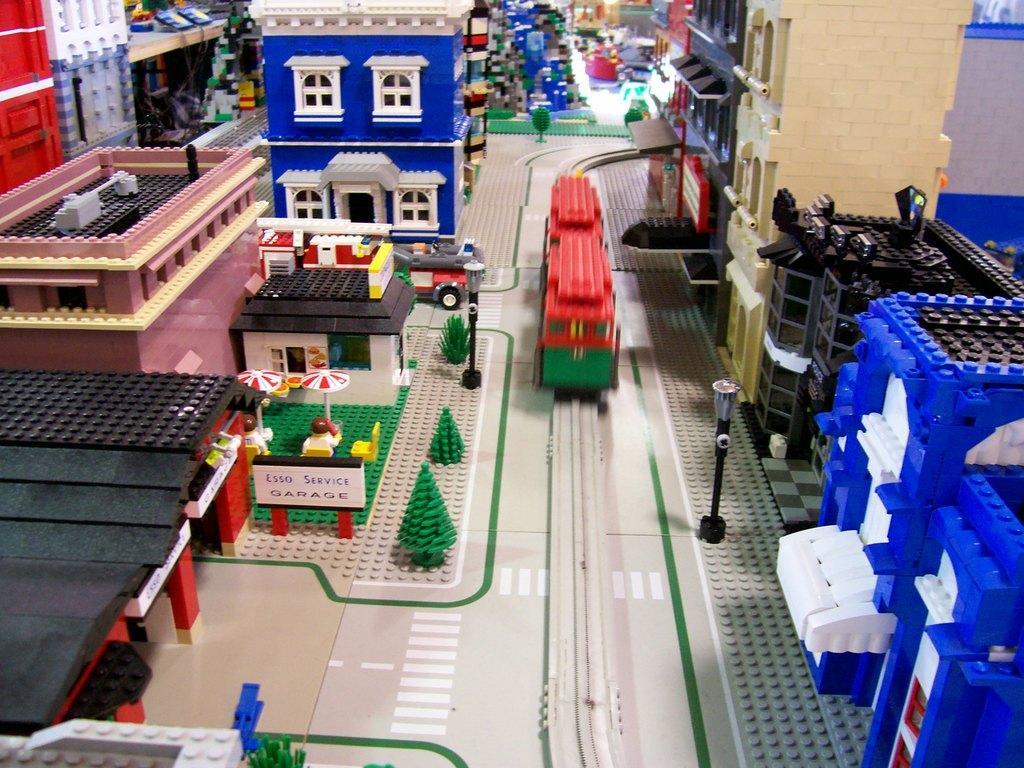Describe this image in one or two sentences. In this image I can see the miniature of few buildings, trees and few vehicles and they are in multi color and they are made with lego. 